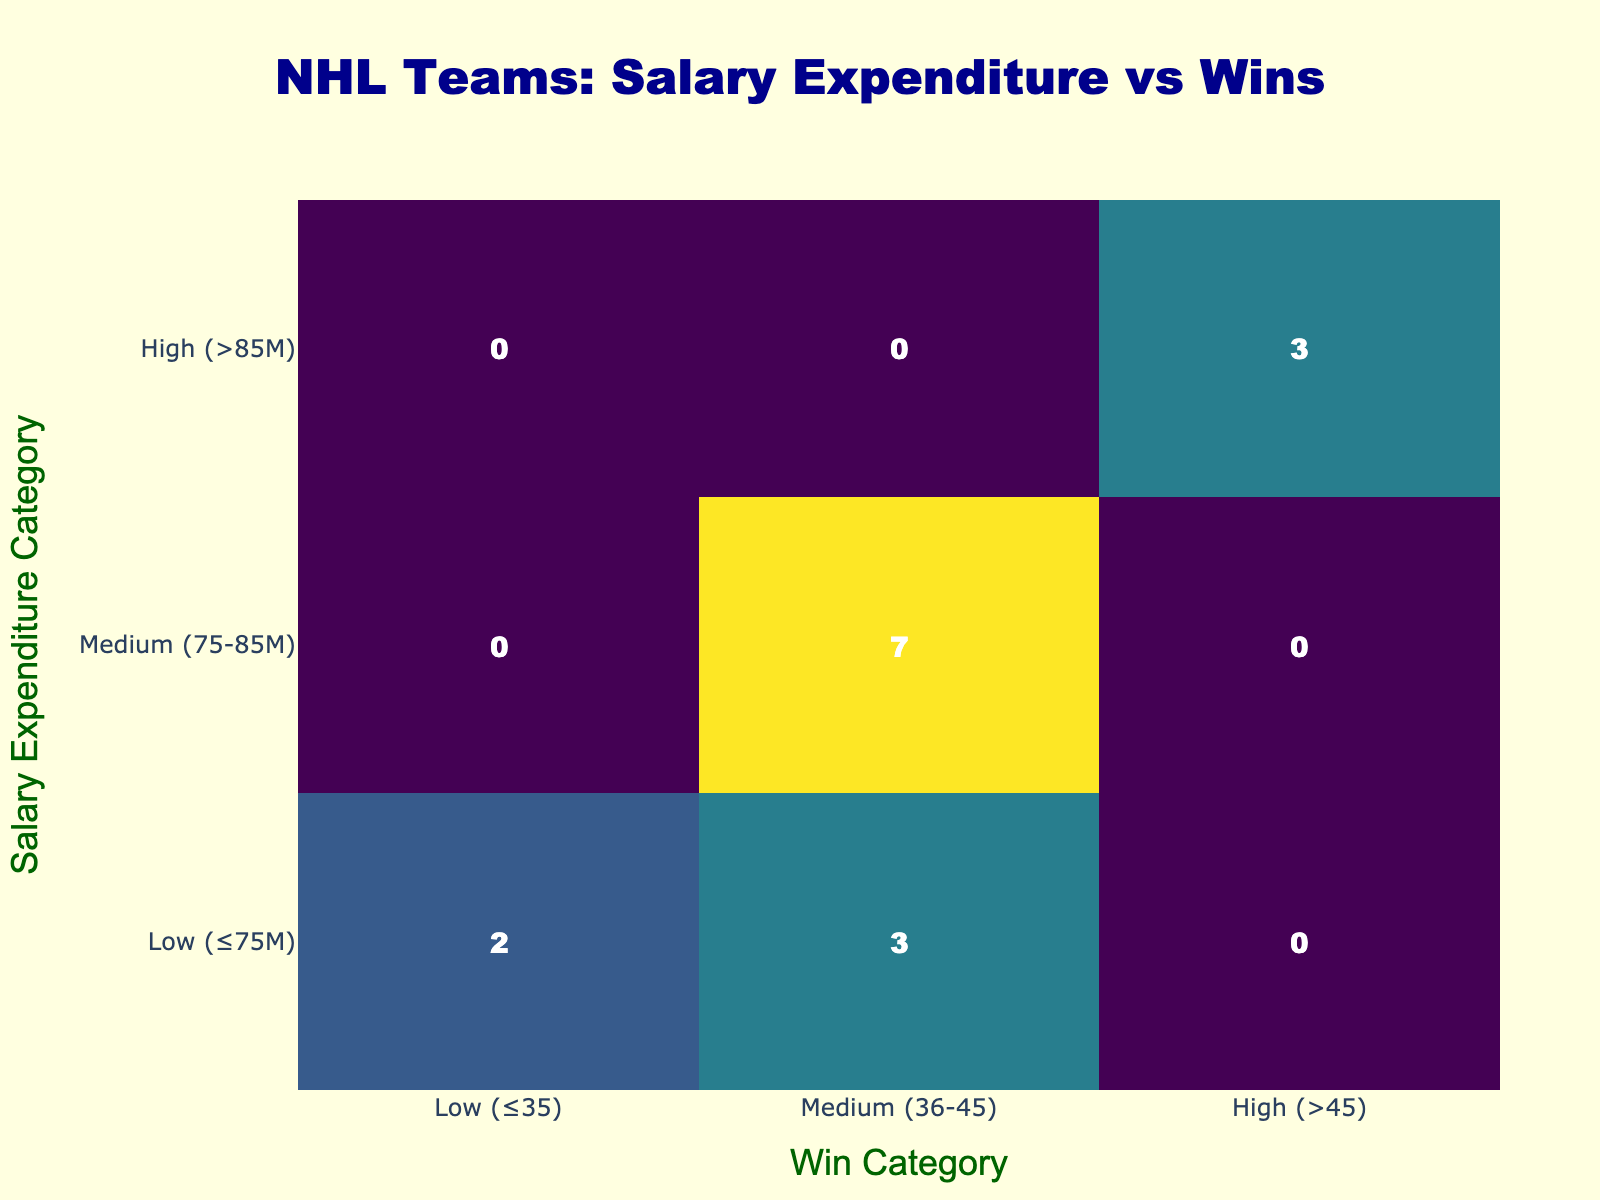What is the win category for the Toronto Maple Leafs? The win category is determined by the number of wins and corresponds to the ranges defined in the table: Low (≤35), Medium (36-45), and High (>45). The Toronto Maple Leafs have 54 wins, which falls into the High (>45) category.
Answer: High (>45) How many teams fall into the Medium win category? To find out how many teams fall into the Medium win category, I check the table for teams categorized as Medium (36-45) based on their wins. The Boston Bruins, Pittsburgh Penguins, Dallas Stars, and Minnesota Wild fall into this category. Counting these teams gives a total of 4.
Answer: 4 Is there any team that falls into the Low salary expenditure category? The Low salary expenditure category comprises teams with a salary of ≤75 million. Checking the table, only the Florida Panthers and Nashville Predators have salaries less than or equal to 75 million, which confirms that there are such teams.
Answer: Yes What is the total number of wins for teams in the High salary expenditure category? The High salary expenditure category includes teams in the salary range of >85 million. The teams are the Toronto Maple Leafs, Boston Bruins, and New York Rangers. Their wins are 54, 49, and 48 respectively. Adding these yields a total of 54 + 49 + 48 = 151 wins.
Answer: 151 Do teams in the High salary expenditure category perform better on average than those in the Medium category? To assess this, I need to calculate the average wins for both categories. The High category (3 teams: 54, 49, 48) has an average of (54 + 49 + 48) / 3 = 50.67. The Medium category (4 teams: 45, 43, 40, 37) averages (45 + 43 + 40 + 37) / 4 = 41.25. Since 50.67 > 41.25, it indicates that teams in the High salary expenditure category perform better on average.
Answer: Yes How many losses did the teams in the Low win category combine for? Teams in the Low win category have 35 or fewer wins. The only team in this category is the Philadelphia Flyers, who have 36 losses. Thus, the combined losses is 36.
Answer: 36 What is the difference in wins between the highest and lowest salary expenditure categories? The highest salary expenditure category (>85 million) includes the Toronto Maple Leafs (54 wins), while the lowest category (≤75 million) includes the Florida Panthers (45 wins) and Nashville Predators (38 wins). To find the difference, I take the max wins (54) - min wins (38), resulting in 54 - 36 = 18.
Answer: 18 